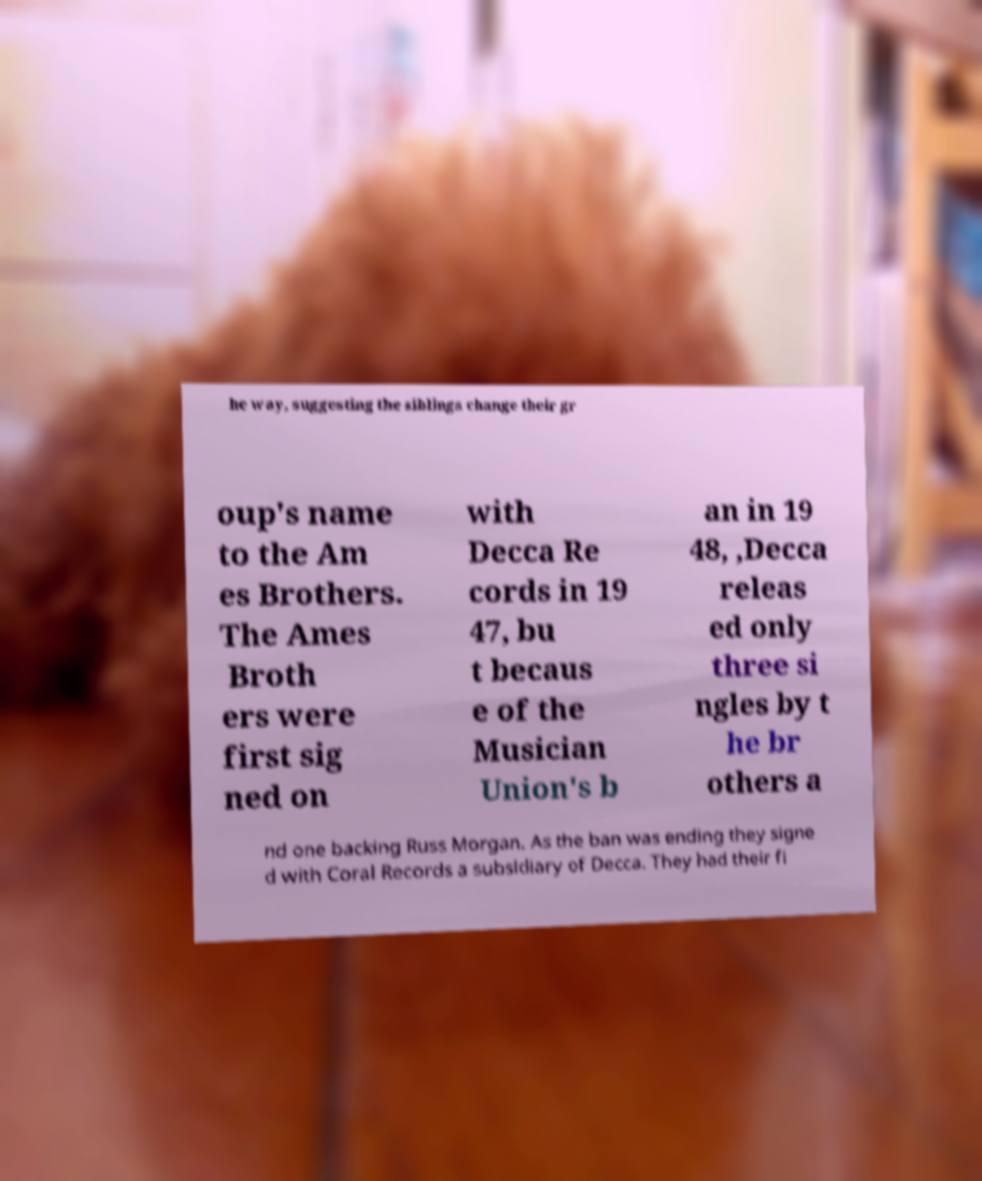What messages or text are displayed in this image? I need them in a readable, typed format. he way, suggesting the siblings change their gr oup's name to the Am es Brothers. The Ames Broth ers were first sig ned on with Decca Re cords in 19 47, bu t becaus e of the Musician Union's b an in 19 48, ,Decca releas ed only three si ngles by t he br others a nd one backing Russ Morgan. As the ban was ending they signe d with Coral Records a subsidiary of Decca. They had their fi 